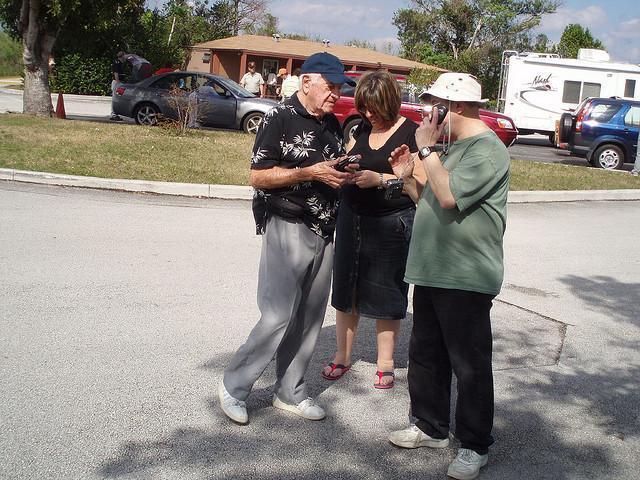Which person is the oldest?
Answer the question by selecting the correct answer among the 4 following choices and explain your choice with a short sentence. The answer should be formatted with the following format: `Answer: choice
Rationale: rationale.`
Options: Right man, middle woman, left man, back man. Answer: left man.
Rationale: The man on the left has gray hair which would probably mean he is older than the other two. 